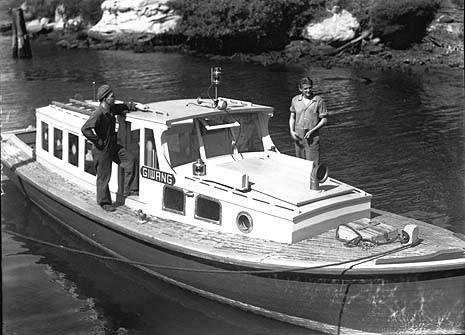What is the last letter in the ship's name?
Keep it brief. G. What color is the picture?
Keep it brief. Black and white. Is this a large ship?
Quick response, please. No. How many boats are there?
Give a very brief answer. 1. 